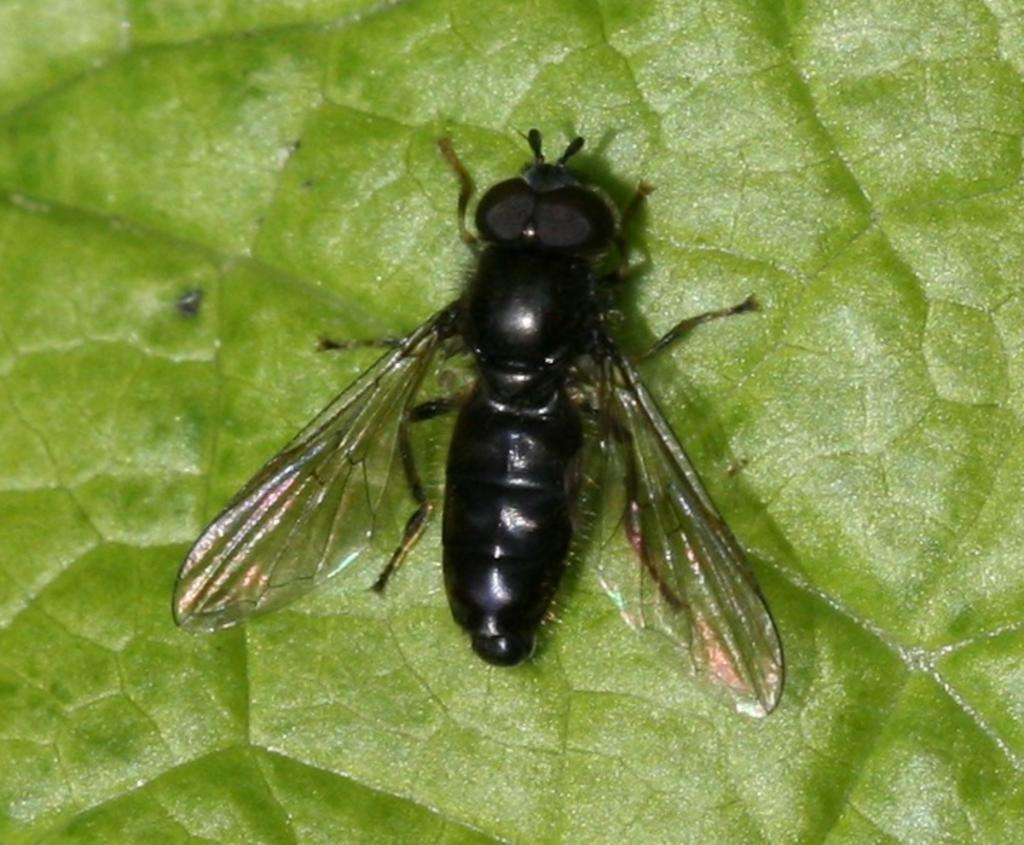What is the main subject of the picture? The main subject of the picture is a bee. Where is the bee located in the picture? The bee is sitting on a leaf in the picture. What are the main features of the bee? The bee has wings, a head, a body, and legs. The bee is also black in color. What type of record is being played by the bee in the picture? There is no record or any indication of music in the picture; it features a bee sitting on a leaf. 